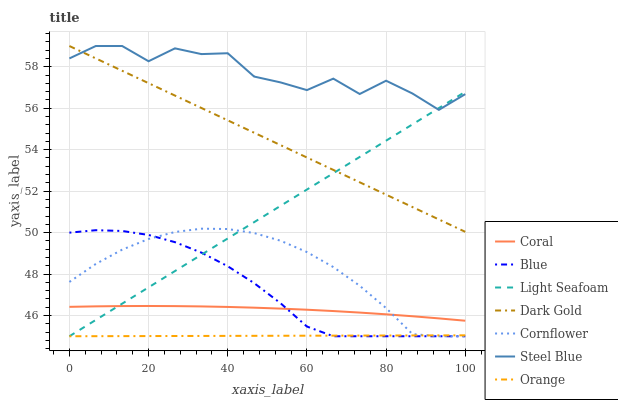Does Orange have the minimum area under the curve?
Answer yes or no. Yes. Does Steel Blue have the maximum area under the curve?
Answer yes or no. Yes. Does Cornflower have the minimum area under the curve?
Answer yes or no. No. Does Cornflower have the maximum area under the curve?
Answer yes or no. No. Is Light Seafoam the smoothest?
Answer yes or no. Yes. Is Steel Blue the roughest?
Answer yes or no. Yes. Is Cornflower the smoothest?
Answer yes or no. No. Is Cornflower the roughest?
Answer yes or no. No. Does Blue have the lowest value?
Answer yes or no. Yes. Does Dark Gold have the lowest value?
Answer yes or no. No. Does Steel Blue have the highest value?
Answer yes or no. Yes. Does Cornflower have the highest value?
Answer yes or no. No. Is Blue less than Steel Blue?
Answer yes or no. Yes. Is Dark Gold greater than Coral?
Answer yes or no. Yes. Does Cornflower intersect Blue?
Answer yes or no. Yes. Is Cornflower less than Blue?
Answer yes or no. No. Is Cornflower greater than Blue?
Answer yes or no. No. Does Blue intersect Steel Blue?
Answer yes or no. No. 